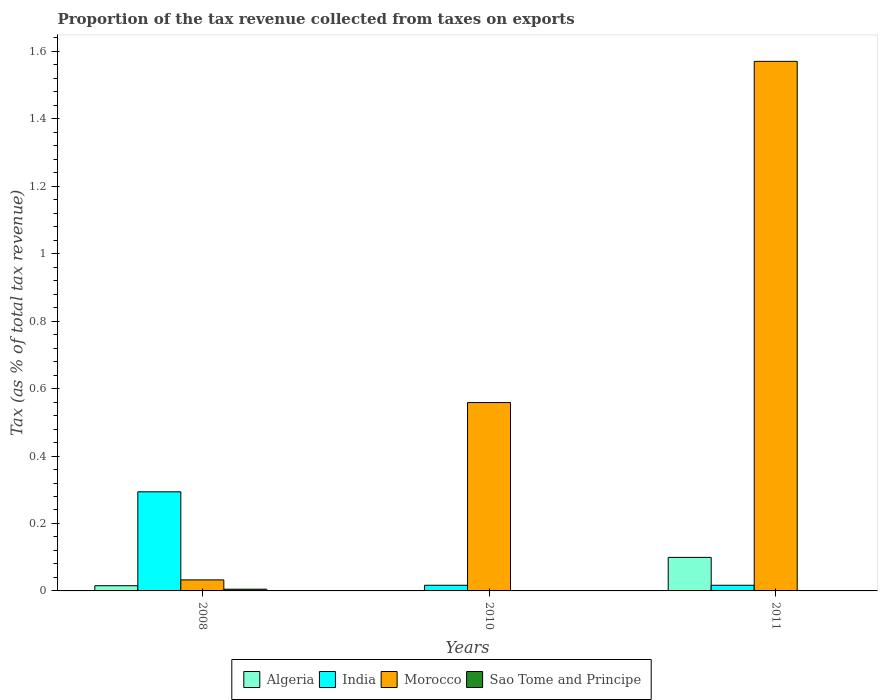How many bars are there on the 2nd tick from the left?
Provide a succinct answer. 4. In how many cases, is the number of bars for a given year not equal to the number of legend labels?
Your answer should be compact. 0. What is the proportion of the tax revenue collected in Algeria in 2008?
Make the answer very short. 0.02. Across all years, what is the maximum proportion of the tax revenue collected in Sao Tome and Principe?
Make the answer very short. 0.01. Across all years, what is the minimum proportion of the tax revenue collected in Morocco?
Ensure brevity in your answer.  0.03. What is the total proportion of the tax revenue collected in Morocco in the graph?
Your answer should be very brief. 2.16. What is the difference between the proportion of the tax revenue collected in Sao Tome and Principe in 2008 and that in 2011?
Offer a terse response. 0. What is the difference between the proportion of the tax revenue collected in India in 2008 and the proportion of the tax revenue collected in Algeria in 2011?
Ensure brevity in your answer.  0.19. What is the average proportion of the tax revenue collected in Sao Tome and Principe per year?
Make the answer very short. 0. In the year 2008, what is the difference between the proportion of the tax revenue collected in Morocco and proportion of the tax revenue collected in Sao Tome and Principe?
Provide a succinct answer. 0.03. In how many years, is the proportion of the tax revenue collected in India greater than 0.56 %?
Ensure brevity in your answer.  0. What is the ratio of the proportion of the tax revenue collected in Morocco in 2008 to that in 2011?
Offer a very short reply. 0.02. Is the proportion of the tax revenue collected in Sao Tome and Principe in 2008 less than that in 2011?
Make the answer very short. No. Is the difference between the proportion of the tax revenue collected in Morocco in 2010 and 2011 greater than the difference between the proportion of the tax revenue collected in Sao Tome and Principe in 2010 and 2011?
Give a very brief answer. No. What is the difference between the highest and the second highest proportion of the tax revenue collected in India?
Offer a very short reply. 0.28. What is the difference between the highest and the lowest proportion of the tax revenue collected in India?
Provide a succinct answer. 0.28. In how many years, is the proportion of the tax revenue collected in India greater than the average proportion of the tax revenue collected in India taken over all years?
Give a very brief answer. 1. What does the 1st bar from the left in 2010 represents?
Give a very brief answer. Algeria. What does the 4th bar from the right in 2010 represents?
Your answer should be very brief. Algeria. Is it the case that in every year, the sum of the proportion of the tax revenue collected in Algeria and proportion of the tax revenue collected in Sao Tome and Principe is greater than the proportion of the tax revenue collected in Morocco?
Provide a succinct answer. No. How many bars are there?
Provide a succinct answer. 12. Are all the bars in the graph horizontal?
Your answer should be very brief. No. Does the graph contain any zero values?
Your answer should be compact. No. How many legend labels are there?
Ensure brevity in your answer.  4. What is the title of the graph?
Your answer should be very brief. Proportion of the tax revenue collected from taxes on exports. Does "Solomon Islands" appear as one of the legend labels in the graph?
Ensure brevity in your answer.  No. What is the label or title of the Y-axis?
Offer a terse response. Tax (as % of total tax revenue). What is the Tax (as % of total tax revenue) of Algeria in 2008?
Offer a terse response. 0.02. What is the Tax (as % of total tax revenue) of India in 2008?
Your answer should be compact. 0.29. What is the Tax (as % of total tax revenue) of Morocco in 2008?
Provide a succinct answer. 0.03. What is the Tax (as % of total tax revenue) of Sao Tome and Principe in 2008?
Offer a terse response. 0.01. What is the Tax (as % of total tax revenue) of Algeria in 2010?
Give a very brief answer. 0. What is the Tax (as % of total tax revenue) in India in 2010?
Provide a short and direct response. 0.02. What is the Tax (as % of total tax revenue) of Morocco in 2010?
Your answer should be compact. 0.56. What is the Tax (as % of total tax revenue) in Sao Tome and Principe in 2010?
Make the answer very short. 0. What is the Tax (as % of total tax revenue) of Algeria in 2011?
Your response must be concise. 0.1. What is the Tax (as % of total tax revenue) in India in 2011?
Offer a very short reply. 0.02. What is the Tax (as % of total tax revenue) in Morocco in 2011?
Give a very brief answer. 1.57. What is the Tax (as % of total tax revenue) in Sao Tome and Principe in 2011?
Offer a very short reply. 0. Across all years, what is the maximum Tax (as % of total tax revenue) of Algeria?
Ensure brevity in your answer.  0.1. Across all years, what is the maximum Tax (as % of total tax revenue) of India?
Keep it short and to the point. 0.29. Across all years, what is the maximum Tax (as % of total tax revenue) in Morocco?
Offer a terse response. 1.57. Across all years, what is the maximum Tax (as % of total tax revenue) of Sao Tome and Principe?
Make the answer very short. 0.01. Across all years, what is the minimum Tax (as % of total tax revenue) in Algeria?
Keep it short and to the point. 0. Across all years, what is the minimum Tax (as % of total tax revenue) in India?
Provide a succinct answer. 0.02. Across all years, what is the minimum Tax (as % of total tax revenue) of Morocco?
Offer a terse response. 0.03. Across all years, what is the minimum Tax (as % of total tax revenue) in Sao Tome and Principe?
Keep it short and to the point. 0. What is the total Tax (as % of total tax revenue) in Algeria in the graph?
Provide a short and direct response. 0.12. What is the total Tax (as % of total tax revenue) of India in the graph?
Ensure brevity in your answer.  0.33. What is the total Tax (as % of total tax revenue) of Morocco in the graph?
Your answer should be very brief. 2.16. What is the total Tax (as % of total tax revenue) of Sao Tome and Principe in the graph?
Provide a succinct answer. 0.01. What is the difference between the Tax (as % of total tax revenue) in Algeria in 2008 and that in 2010?
Offer a very short reply. 0.01. What is the difference between the Tax (as % of total tax revenue) of India in 2008 and that in 2010?
Keep it short and to the point. 0.28. What is the difference between the Tax (as % of total tax revenue) of Morocco in 2008 and that in 2010?
Give a very brief answer. -0.53. What is the difference between the Tax (as % of total tax revenue) of Sao Tome and Principe in 2008 and that in 2010?
Give a very brief answer. 0. What is the difference between the Tax (as % of total tax revenue) in Algeria in 2008 and that in 2011?
Your answer should be compact. -0.08. What is the difference between the Tax (as % of total tax revenue) of India in 2008 and that in 2011?
Make the answer very short. 0.28. What is the difference between the Tax (as % of total tax revenue) in Morocco in 2008 and that in 2011?
Offer a very short reply. -1.54. What is the difference between the Tax (as % of total tax revenue) of Sao Tome and Principe in 2008 and that in 2011?
Give a very brief answer. 0. What is the difference between the Tax (as % of total tax revenue) in Algeria in 2010 and that in 2011?
Your answer should be very brief. -0.1. What is the difference between the Tax (as % of total tax revenue) in Morocco in 2010 and that in 2011?
Offer a terse response. -1.01. What is the difference between the Tax (as % of total tax revenue) of Sao Tome and Principe in 2010 and that in 2011?
Ensure brevity in your answer.  -0. What is the difference between the Tax (as % of total tax revenue) in Algeria in 2008 and the Tax (as % of total tax revenue) in India in 2010?
Offer a very short reply. -0. What is the difference between the Tax (as % of total tax revenue) in Algeria in 2008 and the Tax (as % of total tax revenue) in Morocco in 2010?
Ensure brevity in your answer.  -0.54. What is the difference between the Tax (as % of total tax revenue) of Algeria in 2008 and the Tax (as % of total tax revenue) of Sao Tome and Principe in 2010?
Your response must be concise. 0.01. What is the difference between the Tax (as % of total tax revenue) of India in 2008 and the Tax (as % of total tax revenue) of Morocco in 2010?
Keep it short and to the point. -0.26. What is the difference between the Tax (as % of total tax revenue) of India in 2008 and the Tax (as % of total tax revenue) of Sao Tome and Principe in 2010?
Your response must be concise. 0.29. What is the difference between the Tax (as % of total tax revenue) in Morocco in 2008 and the Tax (as % of total tax revenue) in Sao Tome and Principe in 2010?
Offer a very short reply. 0.03. What is the difference between the Tax (as % of total tax revenue) of Algeria in 2008 and the Tax (as % of total tax revenue) of India in 2011?
Keep it short and to the point. -0. What is the difference between the Tax (as % of total tax revenue) of Algeria in 2008 and the Tax (as % of total tax revenue) of Morocco in 2011?
Your answer should be very brief. -1.55. What is the difference between the Tax (as % of total tax revenue) of Algeria in 2008 and the Tax (as % of total tax revenue) of Sao Tome and Principe in 2011?
Keep it short and to the point. 0.01. What is the difference between the Tax (as % of total tax revenue) of India in 2008 and the Tax (as % of total tax revenue) of Morocco in 2011?
Offer a very short reply. -1.28. What is the difference between the Tax (as % of total tax revenue) in India in 2008 and the Tax (as % of total tax revenue) in Sao Tome and Principe in 2011?
Ensure brevity in your answer.  0.29. What is the difference between the Tax (as % of total tax revenue) of Morocco in 2008 and the Tax (as % of total tax revenue) of Sao Tome and Principe in 2011?
Offer a very short reply. 0.03. What is the difference between the Tax (as % of total tax revenue) in Algeria in 2010 and the Tax (as % of total tax revenue) in India in 2011?
Offer a very short reply. -0.02. What is the difference between the Tax (as % of total tax revenue) of Algeria in 2010 and the Tax (as % of total tax revenue) of Morocco in 2011?
Offer a terse response. -1.57. What is the difference between the Tax (as % of total tax revenue) in Algeria in 2010 and the Tax (as % of total tax revenue) in Sao Tome and Principe in 2011?
Your answer should be very brief. -0. What is the difference between the Tax (as % of total tax revenue) in India in 2010 and the Tax (as % of total tax revenue) in Morocco in 2011?
Ensure brevity in your answer.  -1.55. What is the difference between the Tax (as % of total tax revenue) in India in 2010 and the Tax (as % of total tax revenue) in Sao Tome and Principe in 2011?
Keep it short and to the point. 0.02. What is the difference between the Tax (as % of total tax revenue) in Morocco in 2010 and the Tax (as % of total tax revenue) in Sao Tome and Principe in 2011?
Your response must be concise. 0.56. What is the average Tax (as % of total tax revenue) in Algeria per year?
Ensure brevity in your answer.  0.04. What is the average Tax (as % of total tax revenue) of India per year?
Provide a short and direct response. 0.11. What is the average Tax (as % of total tax revenue) of Morocco per year?
Provide a short and direct response. 0.72. What is the average Tax (as % of total tax revenue) in Sao Tome and Principe per year?
Provide a succinct answer. 0. In the year 2008, what is the difference between the Tax (as % of total tax revenue) of Algeria and Tax (as % of total tax revenue) of India?
Your answer should be very brief. -0.28. In the year 2008, what is the difference between the Tax (as % of total tax revenue) in Algeria and Tax (as % of total tax revenue) in Morocco?
Your response must be concise. -0.02. In the year 2008, what is the difference between the Tax (as % of total tax revenue) of Algeria and Tax (as % of total tax revenue) of Sao Tome and Principe?
Your answer should be very brief. 0.01. In the year 2008, what is the difference between the Tax (as % of total tax revenue) in India and Tax (as % of total tax revenue) in Morocco?
Offer a terse response. 0.26. In the year 2008, what is the difference between the Tax (as % of total tax revenue) in India and Tax (as % of total tax revenue) in Sao Tome and Principe?
Your response must be concise. 0.29. In the year 2008, what is the difference between the Tax (as % of total tax revenue) of Morocco and Tax (as % of total tax revenue) of Sao Tome and Principe?
Your answer should be compact. 0.03. In the year 2010, what is the difference between the Tax (as % of total tax revenue) in Algeria and Tax (as % of total tax revenue) in India?
Offer a very short reply. -0.02. In the year 2010, what is the difference between the Tax (as % of total tax revenue) in Algeria and Tax (as % of total tax revenue) in Morocco?
Keep it short and to the point. -0.56. In the year 2010, what is the difference between the Tax (as % of total tax revenue) of Algeria and Tax (as % of total tax revenue) of Sao Tome and Principe?
Offer a very short reply. -0. In the year 2010, what is the difference between the Tax (as % of total tax revenue) in India and Tax (as % of total tax revenue) in Morocco?
Your answer should be compact. -0.54. In the year 2010, what is the difference between the Tax (as % of total tax revenue) of India and Tax (as % of total tax revenue) of Sao Tome and Principe?
Make the answer very short. 0.02. In the year 2010, what is the difference between the Tax (as % of total tax revenue) of Morocco and Tax (as % of total tax revenue) of Sao Tome and Principe?
Give a very brief answer. 0.56. In the year 2011, what is the difference between the Tax (as % of total tax revenue) of Algeria and Tax (as % of total tax revenue) of India?
Ensure brevity in your answer.  0.08. In the year 2011, what is the difference between the Tax (as % of total tax revenue) of Algeria and Tax (as % of total tax revenue) of Morocco?
Your answer should be compact. -1.47. In the year 2011, what is the difference between the Tax (as % of total tax revenue) of Algeria and Tax (as % of total tax revenue) of Sao Tome and Principe?
Offer a terse response. 0.1. In the year 2011, what is the difference between the Tax (as % of total tax revenue) of India and Tax (as % of total tax revenue) of Morocco?
Make the answer very short. -1.55. In the year 2011, what is the difference between the Tax (as % of total tax revenue) in India and Tax (as % of total tax revenue) in Sao Tome and Principe?
Offer a terse response. 0.02. In the year 2011, what is the difference between the Tax (as % of total tax revenue) of Morocco and Tax (as % of total tax revenue) of Sao Tome and Principe?
Provide a short and direct response. 1.57. What is the ratio of the Tax (as % of total tax revenue) in Algeria in 2008 to that in 2010?
Provide a short and direct response. 21.19. What is the ratio of the Tax (as % of total tax revenue) of India in 2008 to that in 2010?
Make the answer very short. 17.53. What is the ratio of the Tax (as % of total tax revenue) of Morocco in 2008 to that in 2010?
Keep it short and to the point. 0.06. What is the ratio of the Tax (as % of total tax revenue) in Sao Tome and Principe in 2008 to that in 2010?
Your answer should be very brief. 5.8. What is the ratio of the Tax (as % of total tax revenue) in Algeria in 2008 to that in 2011?
Your response must be concise. 0.15. What is the ratio of the Tax (as % of total tax revenue) of India in 2008 to that in 2011?
Your response must be concise. 17.53. What is the ratio of the Tax (as % of total tax revenue) of Morocco in 2008 to that in 2011?
Provide a succinct answer. 0.02. What is the ratio of the Tax (as % of total tax revenue) of Sao Tome and Principe in 2008 to that in 2011?
Your answer should be very brief. 4.43. What is the ratio of the Tax (as % of total tax revenue) of Algeria in 2010 to that in 2011?
Make the answer very short. 0.01. What is the ratio of the Tax (as % of total tax revenue) of India in 2010 to that in 2011?
Offer a very short reply. 1. What is the ratio of the Tax (as % of total tax revenue) in Morocco in 2010 to that in 2011?
Your response must be concise. 0.36. What is the ratio of the Tax (as % of total tax revenue) in Sao Tome and Principe in 2010 to that in 2011?
Your answer should be very brief. 0.76. What is the difference between the highest and the second highest Tax (as % of total tax revenue) of Algeria?
Your answer should be very brief. 0.08. What is the difference between the highest and the second highest Tax (as % of total tax revenue) in India?
Make the answer very short. 0.28. What is the difference between the highest and the second highest Tax (as % of total tax revenue) in Morocco?
Give a very brief answer. 1.01. What is the difference between the highest and the second highest Tax (as % of total tax revenue) in Sao Tome and Principe?
Provide a short and direct response. 0. What is the difference between the highest and the lowest Tax (as % of total tax revenue) of Algeria?
Give a very brief answer. 0.1. What is the difference between the highest and the lowest Tax (as % of total tax revenue) in India?
Give a very brief answer. 0.28. What is the difference between the highest and the lowest Tax (as % of total tax revenue) of Morocco?
Provide a short and direct response. 1.54. What is the difference between the highest and the lowest Tax (as % of total tax revenue) in Sao Tome and Principe?
Give a very brief answer. 0. 